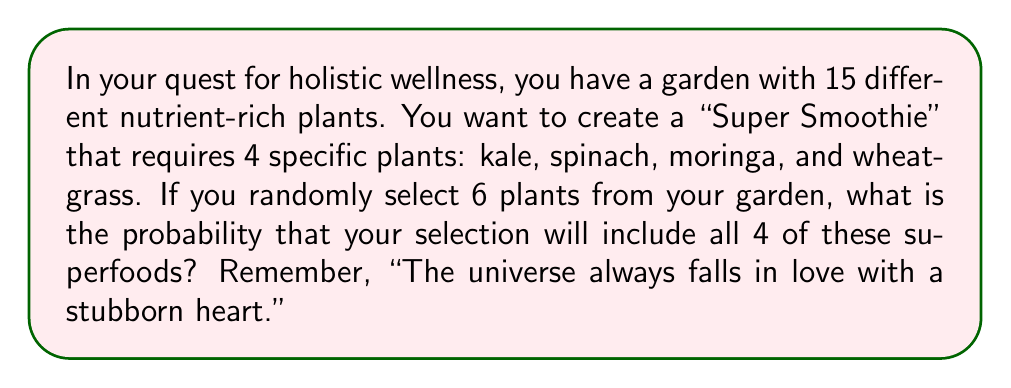What is the answer to this math problem? Let's approach this step-by-step, channeling the positive energy of the universe:

1) First, we need to calculate the total number of ways to select 6 plants from 15. This is given by the combination formula:

   $$\binom{15}{6} = \frac{15!}{6!(15-6)!} = \frac{15!}{6!9!} = 5005$$

2) Now, we need to calculate the number of favorable outcomes. To have all 4 specific plants, we must:
   - Select all 4 specific plants
   - Select 2 more plants from the remaining 11

3) The number of ways to select 2 plants from 11 is:

   $$\binom{11}{2} = \frac{11!}{2!9!} = 55$$

4) Therefore, the number of favorable outcomes is 55.

5) The probability is the number of favorable outcomes divided by the total number of possible outcomes:

   $$P(\text{all 4 superfoods}) = \frac{55}{5005} = \frac{11}{1001} \approx 0.01099$$

6) To express this as a percentage:

   $$\frac{11}{1001} \times 100\% \approx 1.099\%$$

Remember, as we say in nutrition, "Small changes can make a big difference!" This small probability can lead to a super-nutritious smoothie!
Answer: $\frac{11}{1001}$ or approximately 1.099% 